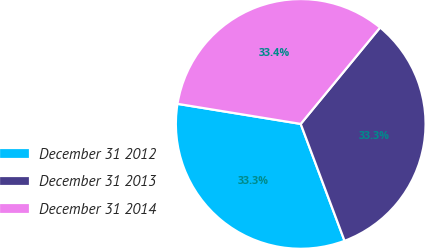Convert chart to OTSL. <chart><loc_0><loc_0><loc_500><loc_500><pie_chart><fcel>December 31 2012<fcel>December 31 2013<fcel>December 31 2014<nl><fcel>33.28%<fcel>33.33%<fcel>33.39%<nl></chart> 